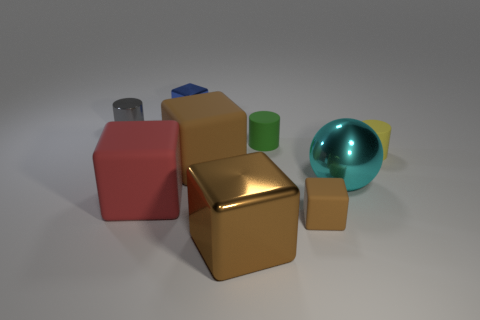Subtract all brown blocks. How many were subtracted if there are2brown blocks left? 1 Subtract all gray cylinders. How many brown cubes are left? 3 Subtract all red cubes. How many cubes are left? 4 Subtract all cyan cubes. Subtract all green cylinders. How many cubes are left? 5 Add 1 green metal balls. How many objects exist? 10 Subtract all spheres. How many objects are left? 8 Add 7 blue blocks. How many blue blocks are left? 8 Add 8 yellow matte cylinders. How many yellow matte cylinders exist? 9 Subtract 0 red cylinders. How many objects are left? 9 Subtract all purple things. Subtract all large matte objects. How many objects are left? 7 